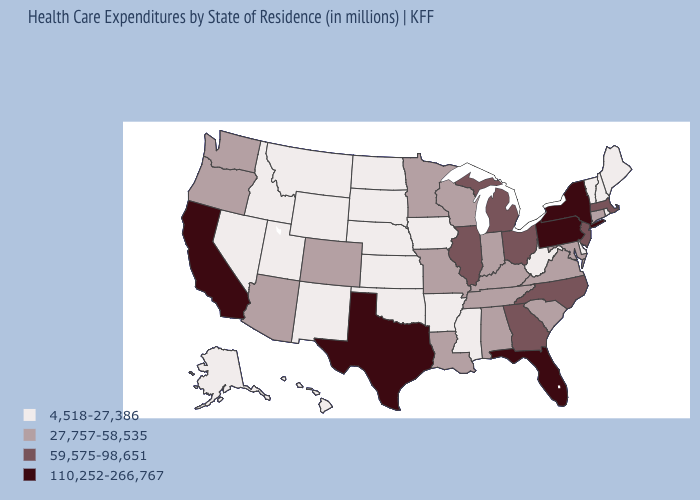What is the value of Washington?
Write a very short answer. 27,757-58,535. Does Massachusetts have a lower value than California?
Short answer required. Yes. What is the value of Oklahoma?
Keep it brief. 4,518-27,386. What is the highest value in the USA?
Answer briefly. 110,252-266,767. Does the map have missing data?
Quick response, please. No. What is the value of Pennsylvania?
Write a very short answer. 110,252-266,767. Which states have the lowest value in the West?
Quick response, please. Alaska, Hawaii, Idaho, Montana, Nevada, New Mexico, Utah, Wyoming. What is the value of Alabama?
Concise answer only. 27,757-58,535. Does Texas have the same value as North Carolina?
Answer briefly. No. Name the states that have a value in the range 110,252-266,767?
Be succinct. California, Florida, New York, Pennsylvania, Texas. Does New Hampshire have the lowest value in the Northeast?
Keep it brief. Yes. What is the lowest value in the MidWest?
Give a very brief answer. 4,518-27,386. Among the states that border Mississippi , does Alabama have the highest value?
Quick response, please. Yes. Among the states that border Nebraska , which have the highest value?
Answer briefly. Colorado, Missouri. What is the value of Missouri?
Be succinct. 27,757-58,535. 